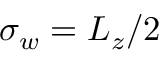<formula> <loc_0><loc_0><loc_500><loc_500>\sigma _ { w } = L _ { z } / 2</formula> 